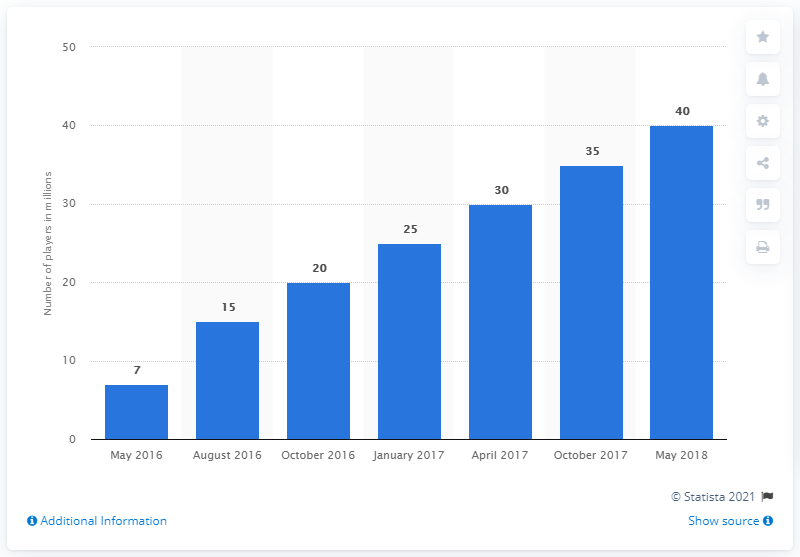Give some essential details in this illustration. As of May 2018, approximately 40 million people had played Overwatch. Of the bars with values equal to or over 30, a total of 3 bars meet this criteria. The earliest month reported in this graph is May 2016. 